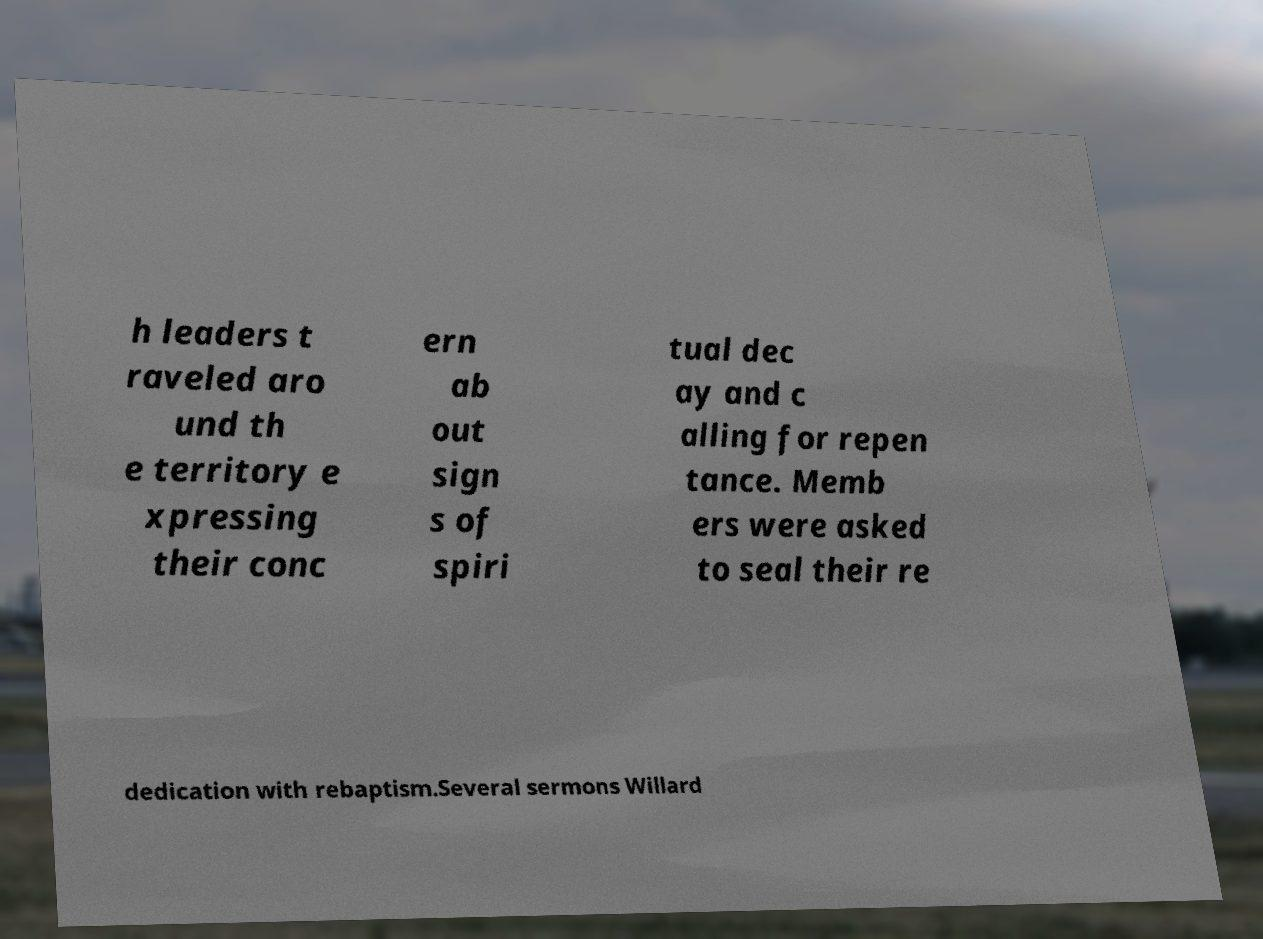Can you read and provide the text displayed in the image?This photo seems to have some interesting text. Can you extract and type it out for me? h leaders t raveled aro und th e territory e xpressing their conc ern ab out sign s of spiri tual dec ay and c alling for repen tance. Memb ers were asked to seal their re dedication with rebaptism.Several sermons Willard 